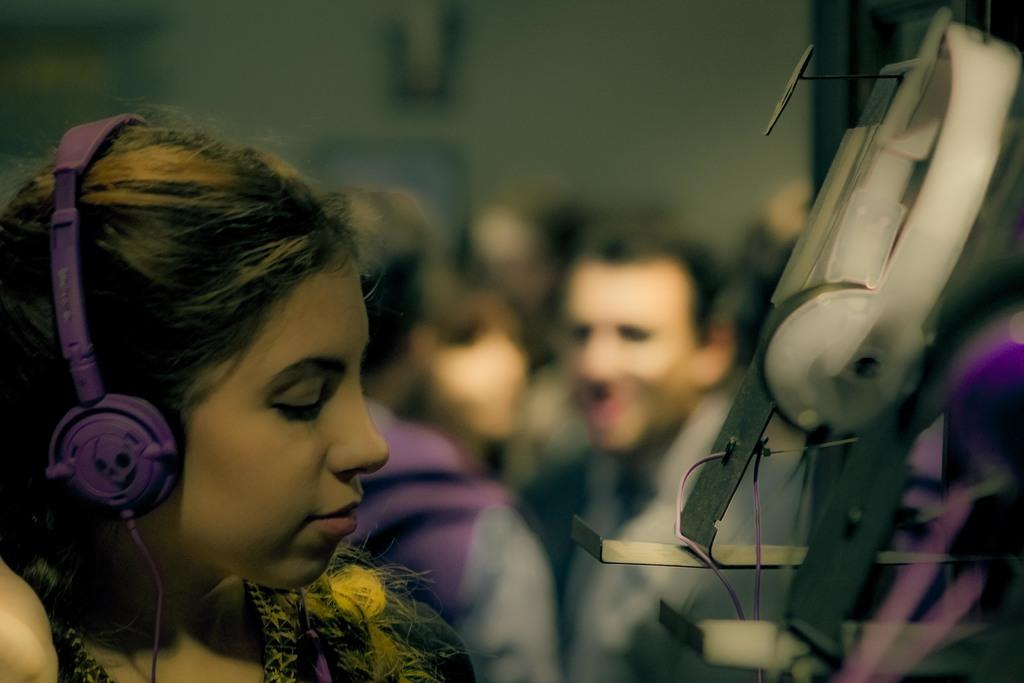Who is present in the image? There is a woman in the image. What is the woman wearing on her head? The woman is wearing a headphone. Can you describe the background of the image? There are people standing in the background of the image. What type of yarn can be seen in the image? There is no yarn present in the image. How thick is the fog in the image? There is no fog present in the image. 